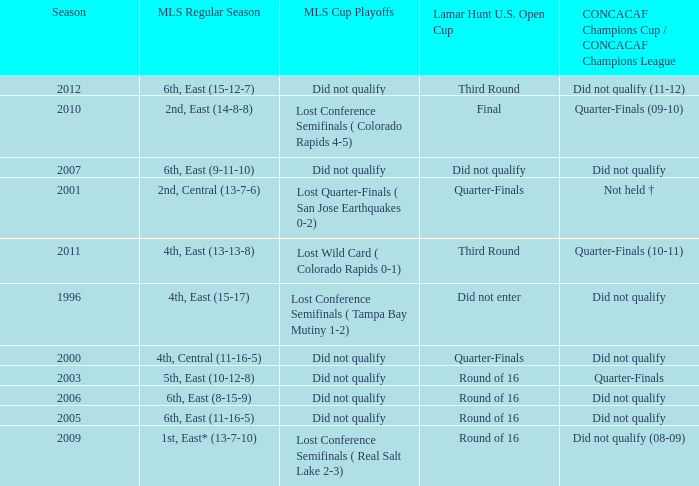What was the season when mls regular season was 6th, east (9-11-10)? 2007.0. 